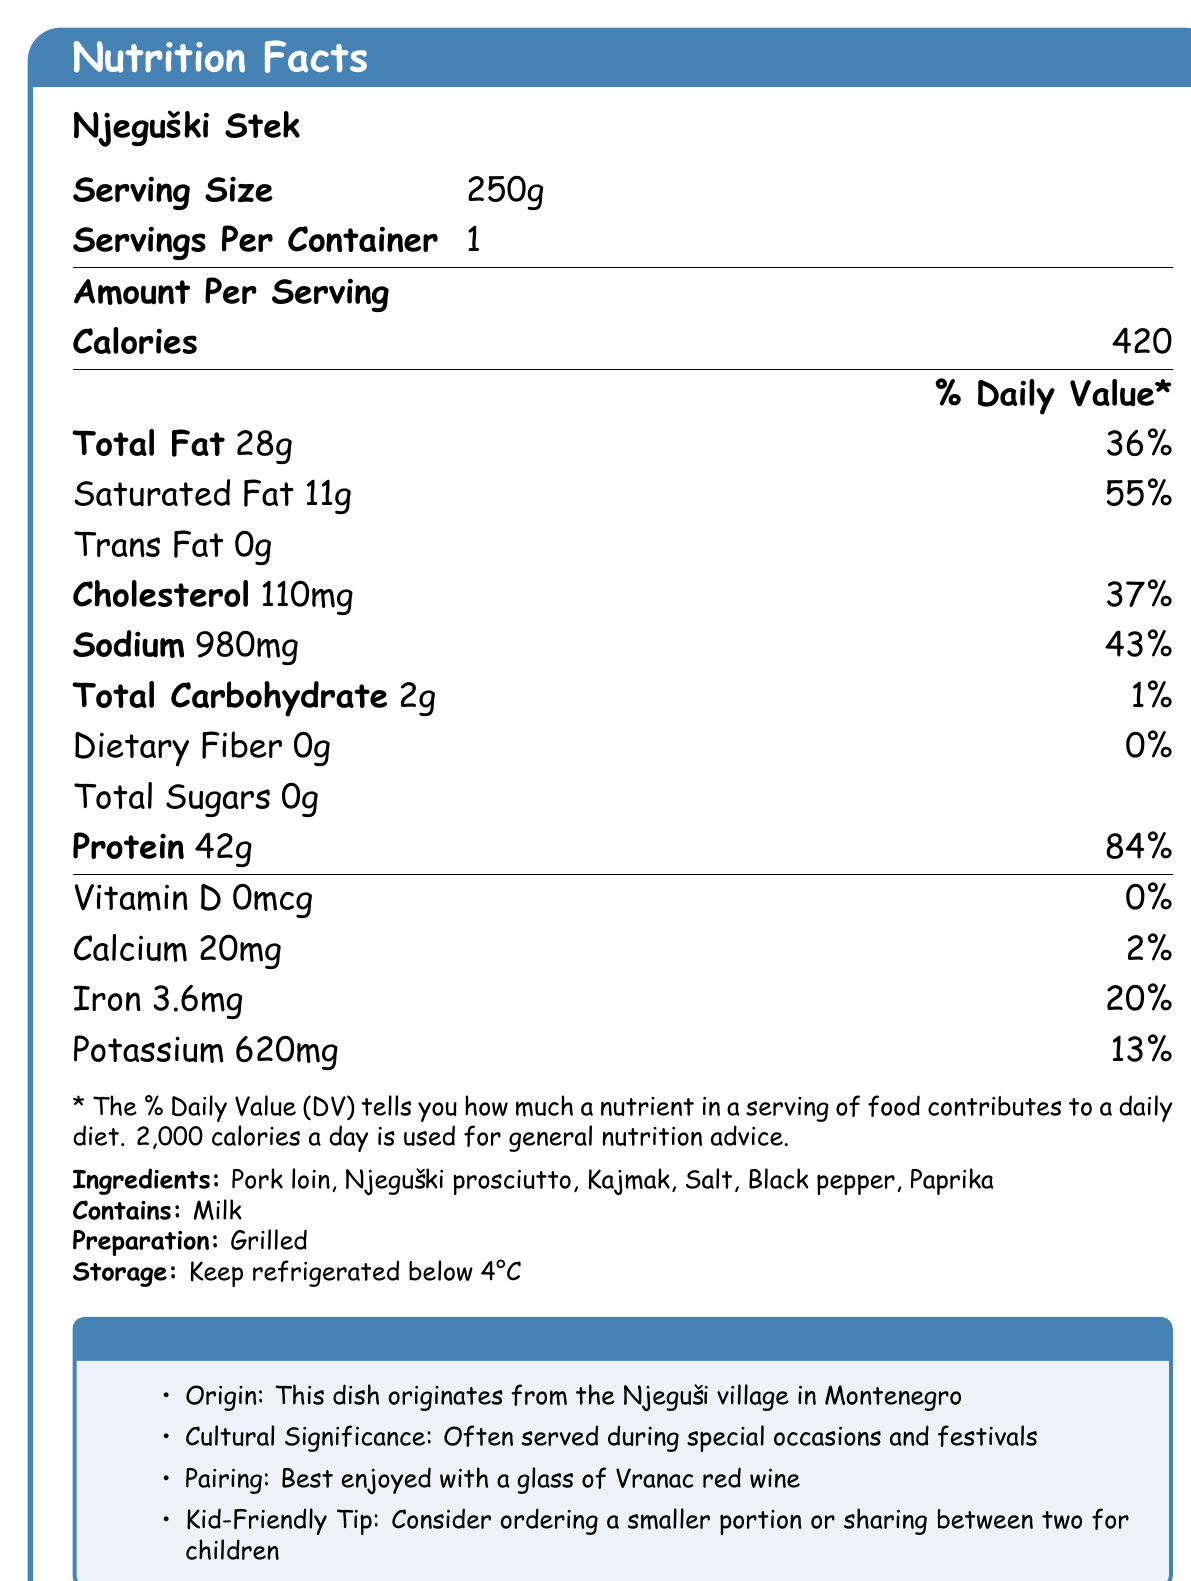what is the serving size of Njeguški Stek? The serving size is clearly listed as 250g under "Serving Size".
Answer: 250g what is the calorie count per serving? The document states that the number of calories per serving is 420.
Answer: 420 how much protein does one serving contain? Under "Amount Per Serving," it lists 42g of protein.
Answer: 42g does this dish contain any dietary fiber? The dietary fiber content is listed as 0g.
Answer: No what is the main ingredient in Njeguški Stek? The first ingredient listed, which is usually the primary ingredient, is Pork loin.
Answer: Pork loin how is Njeguški Stek prepared? The preparation method mentioned is "Grilled."
Answer: Grilled which allergen is present in Njeguški Stek? The document states that it contains Milk under the "Contains" section.
Answer: Milk what is the dish's cultural significance? In the tour guide notes, it mentions that Njeguški Stek is often served during special occasions and festivals.
Answer: Often served during special occasions and festivals which nutrient has the highest % Daily Value per serving? A. Saturated Fat B. Protein C. Cholesterol Protein has the highest % Daily Value (84%) compared to Saturated Fat (55%) and Cholesterol (37%).
Answer: B. Protein how much sodium does one serving of Njeguški Stek contain? A. 500mg B. 980mg C. 1200mg The document lists the sodium content as 980mg.
Answer: B. 980mg is Njeguški Stek a high-fat dish? The total fat content per serving is 28g, which is 36% of the Daily Value.
Answer: Yes does Njeguški Stek contain any Vitamin D? The Vitamin D content is listed as 0mcg, giving 0% Daily Value.
Answer: No what are the storage instructions for Njeguški Stek? The storage instructions state to keep it refrigerated below 4°C.
Answer: Keep refrigerated below 4°C what beverage pairs well with this dish according to the document? The tour guide notes suggest pairing Njeguški Stek with a glass of Vranac red wine.
Answer: Vranac red wine what are some kid-friendly suggestions for serving Njeguški Stek? The tour guide notes recommend these tips for a kid-friendly dining experience.
Answer: Consider ordering a smaller portion or sharing between two for children summarize the main information provided about Njeguški Stek. The document provides comprehensive nutritional information, origin, cultural significance, preparation method, storage instructions, and pairing suggestions for Njeguški Stek.
Answer: Njeguški Stek is a traditional Montenegrin dish with a serving size of 250g, containing 420 calories per serving. It is high in protein and fat, contains milk as an allergen, and should be kept refrigerated below 4°C. The dish originates from the Njeguši village, is culturally significant, and pairs well with Vranac red wine. For children, it is suggested to order smaller portions or share. what are the cholesterol and iron levels in Njeguški Stek? Cholesterol is listed as 110mg with a daily value of 37%, and iron is 3.6mg with a daily value of 20%.
Answer: Cholesterol: 110mg, Iron: 3.6mg is this dish suitable for someone on a low-carb diet? The total carbohydrate content is 2g, which is 1% of the Daily Value, making it suitable for a low-carb diet.
Answer: Yes who is the supplier of Njeguški Stek? The document does not provide any information about the supplier of the dish.
Answer: Not enough information 